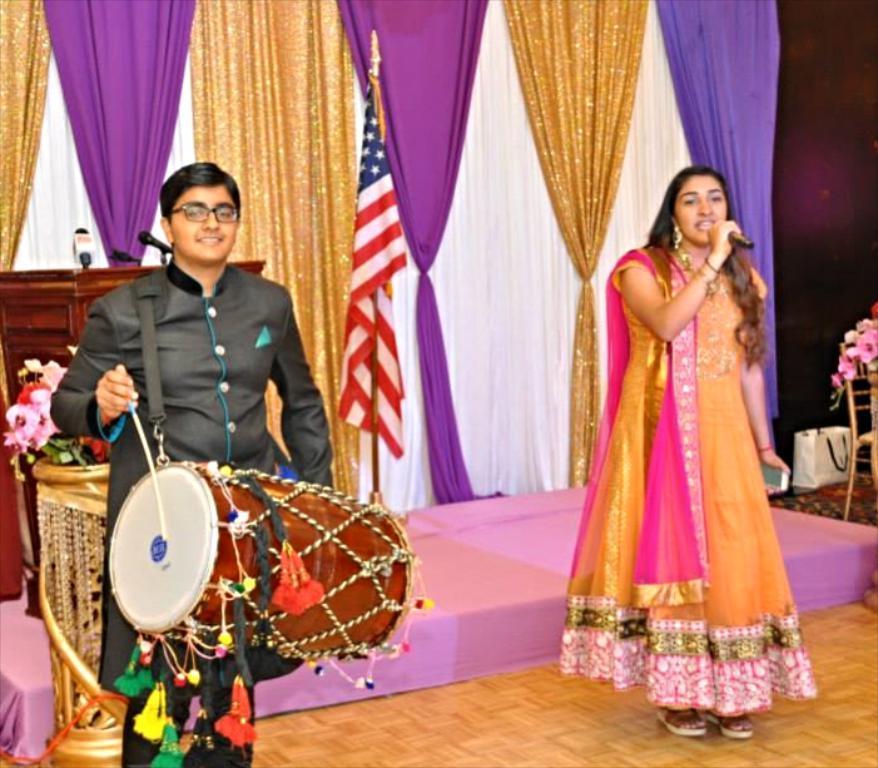How would you summarize this image in a sentence or two? this picture shows a man holding drum in his hand and we see woman standing and singing with the help of a microphone and we see a podium on their back and a flag 